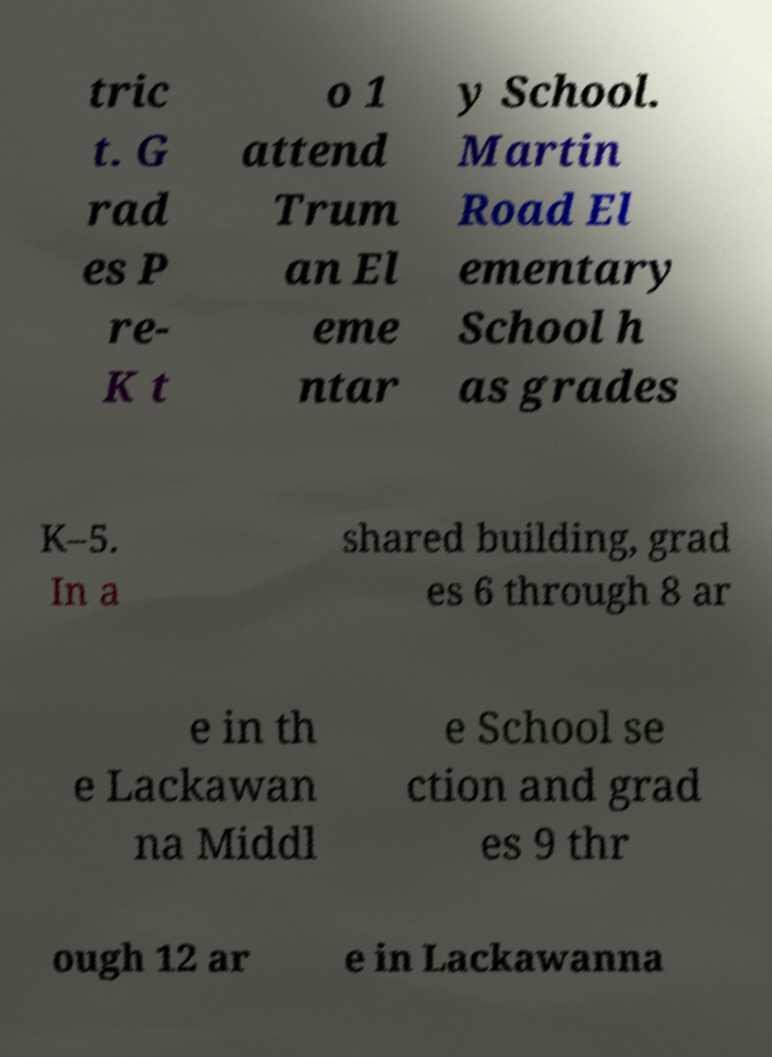Please read and relay the text visible in this image. What does it say? tric t. G rad es P re- K t o 1 attend Trum an El eme ntar y School. Martin Road El ementary School h as grades K–5. In a shared building, grad es 6 through 8 ar e in th e Lackawan na Middl e School se ction and grad es 9 thr ough 12 ar e in Lackawanna 